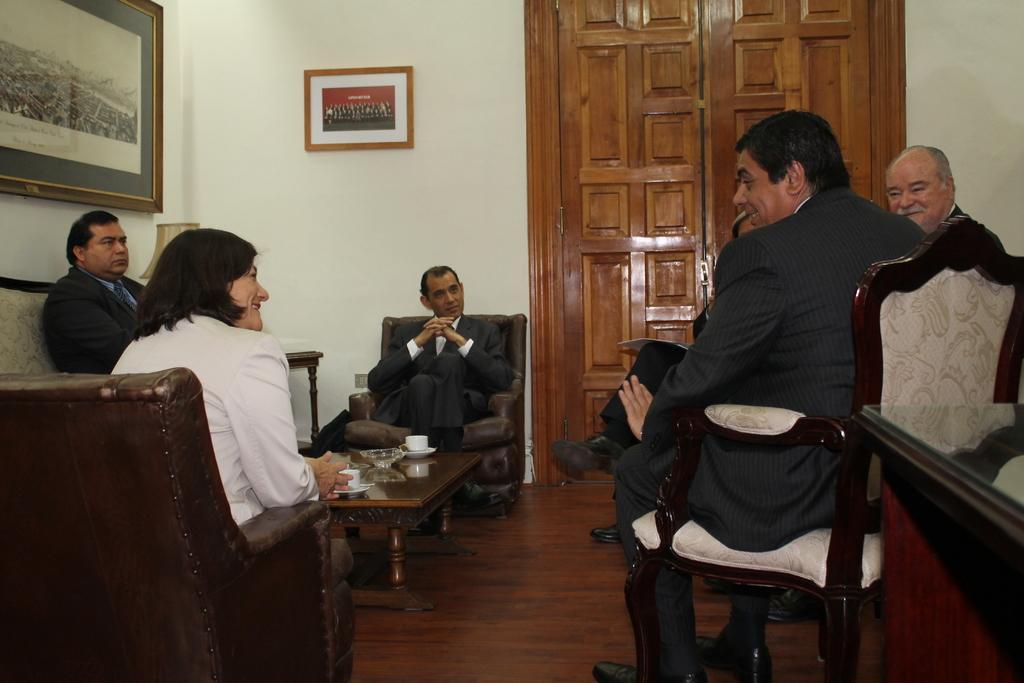Please provide a concise description of this image. This picture is taken in a house in a office. In the foreground of the picture there is a woman and a man sitting in chairs. In the background there is a door. On the top right there is a man and smiling. On the left there is a man seated in couch. In the center of the background there is a man seated in black suit. In the center of the picture there is a table, on the table there are cups and a bowl. On the top left there are frames to the wall. 